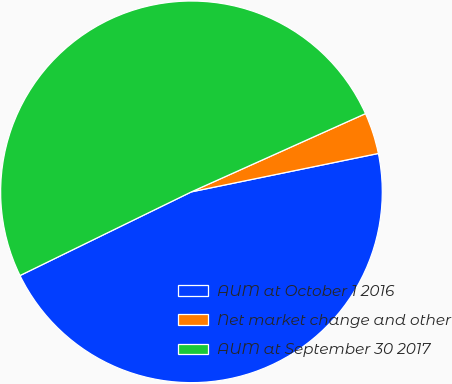Convert chart to OTSL. <chart><loc_0><loc_0><loc_500><loc_500><pie_chart><fcel>AUM at October 1 2016<fcel>Net market change and other<fcel>AUM at September 30 2017<nl><fcel>45.99%<fcel>3.5%<fcel>50.5%<nl></chart> 